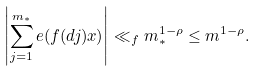Convert formula to latex. <formula><loc_0><loc_0><loc_500><loc_500>\left | \sum _ { j = 1 } ^ { m _ { \ast } } e ( f ( d j ) x ) \right | \ll _ { f } m _ { \ast } ^ { 1 - \rho } \leq m ^ { 1 - \rho } .</formula> 